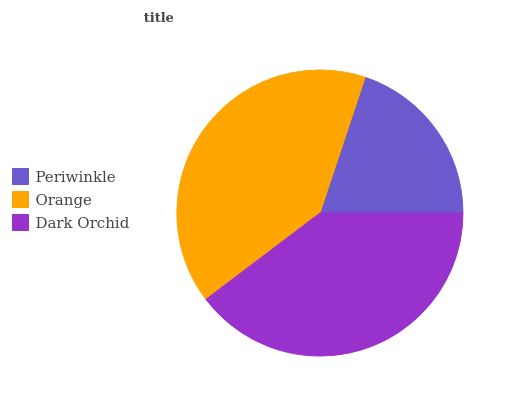Is Periwinkle the minimum?
Answer yes or no. Yes. Is Orange the maximum?
Answer yes or no. Yes. Is Dark Orchid the minimum?
Answer yes or no. No. Is Dark Orchid the maximum?
Answer yes or no. No. Is Orange greater than Dark Orchid?
Answer yes or no. Yes. Is Dark Orchid less than Orange?
Answer yes or no. Yes. Is Dark Orchid greater than Orange?
Answer yes or no. No. Is Orange less than Dark Orchid?
Answer yes or no. No. Is Dark Orchid the high median?
Answer yes or no. Yes. Is Dark Orchid the low median?
Answer yes or no. Yes. Is Orange the high median?
Answer yes or no. No. Is Orange the low median?
Answer yes or no. No. 